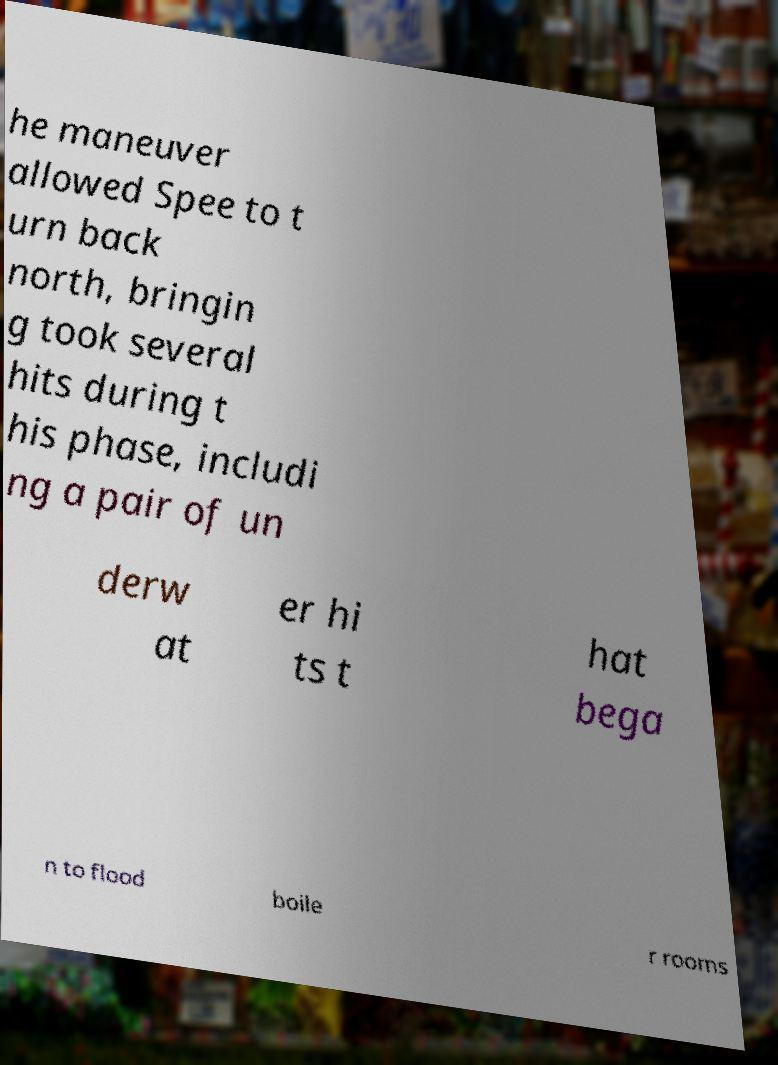Please identify and transcribe the text found in this image. he maneuver allowed Spee to t urn back north, bringin g took several hits during t his phase, includi ng a pair of un derw at er hi ts t hat bega n to flood boile r rooms 